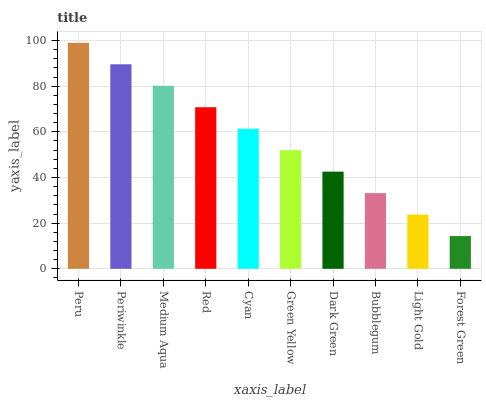Is Periwinkle the minimum?
Answer yes or no. No. Is Periwinkle the maximum?
Answer yes or no. No. Is Peru greater than Periwinkle?
Answer yes or no. Yes. Is Periwinkle less than Peru?
Answer yes or no. Yes. Is Periwinkle greater than Peru?
Answer yes or no. No. Is Peru less than Periwinkle?
Answer yes or no. No. Is Cyan the high median?
Answer yes or no. Yes. Is Green Yellow the low median?
Answer yes or no. Yes. Is Red the high median?
Answer yes or no. No. Is Light Gold the low median?
Answer yes or no. No. 